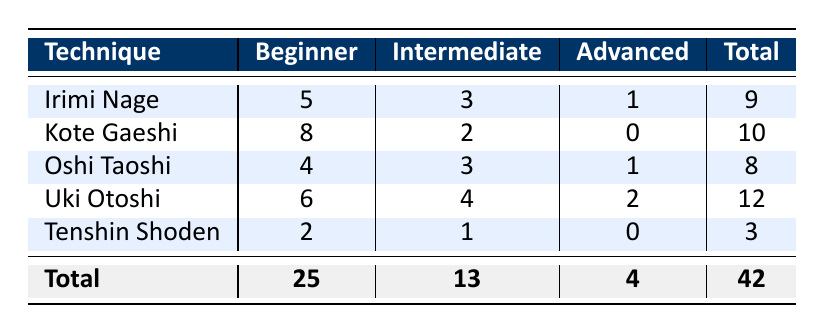What technique had the highest number of injury reports for beginners? The table shows that Kote Gaeshi has the highest number of injury reports for beginners, with a total of 8 reports.
Answer: Kote Gaeshi How many total injury reports are there for advanced levels? By looking at the total injury reports for the advanced level, we see 1 from Irimi Nage, 0 from Kote Gaeshi, 1 from Oshi Taoshi, 2 from Uki Otoshi, and 0 from Tenshin Shoden. Adding these gives 1 + 0 + 1 + 2 + 0 = 4 total injury reports for advanced levels.
Answer: 4 Is it true that the total number of injury reports for beginners is greater than for intermediates? The total number of injury reports for beginners is 25, while for intermediates it is 13. Since 25 is greater than 13, the statement is true.
Answer: Yes What is the average number of injury reports for the technique Uki Otoshi across all experience levels? The injury reports for Uki Otoshi are 6 for beginners, 4 for intermediates, and 2 for advanced, which totals to 6 + 4 + 2 = 12 reports. Since there are 3 experience levels, the average is 12/3 = 4.
Answer: 4 Which experience level has the lowest number of injury reports overall? By comparing the totals of each experience level, we see the total number of injury reports is 25 for beginners, 13 for intermediates, and 4 for advanced. The lowest total comes from the advanced level, which has only 4 injury reports.
Answer: Advanced 